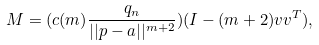<formula> <loc_0><loc_0><loc_500><loc_500>M = ( c ( m ) \frac { q _ { n } } { | | p - a | | ^ { m + 2 } } ) ( I - ( m + 2 ) v v ^ { T } ) ,</formula> 